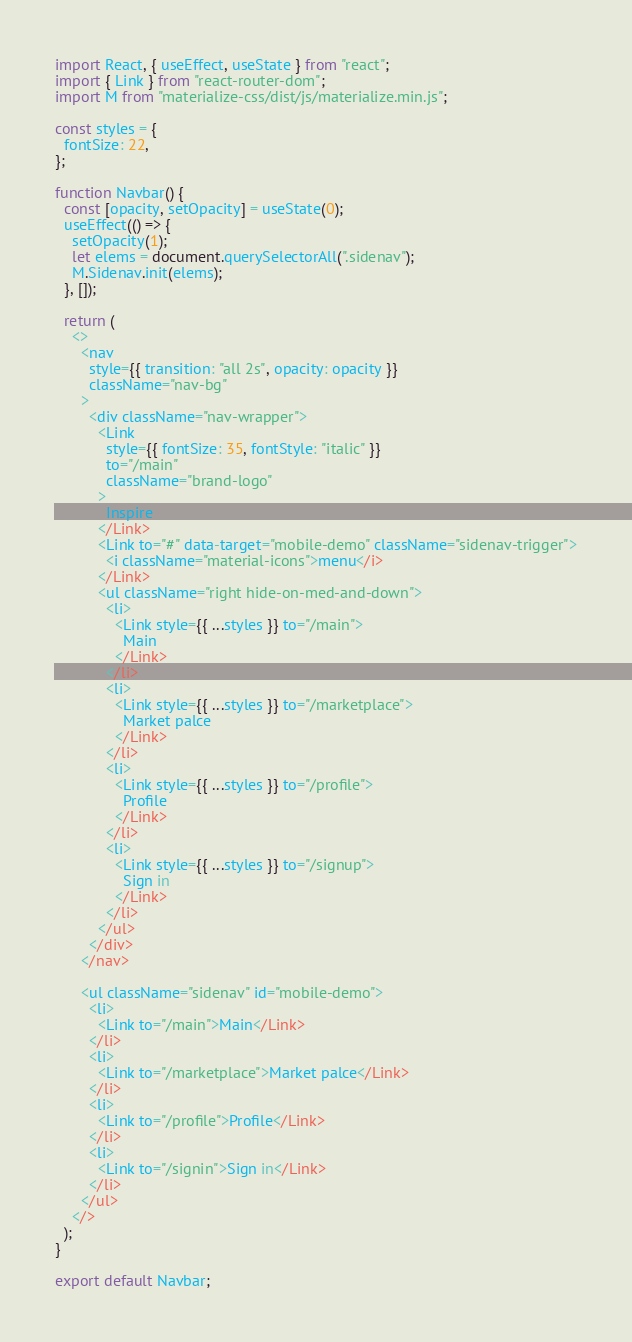<code> <loc_0><loc_0><loc_500><loc_500><_JavaScript_>import React, { useEffect, useState } from "react";
import { Link } from "react-router-dom";
import M from "materialize-css/dist/js/materialize.min.js";

const styles = {
  fontSize: 22,
};

function Navbar() {
  const [opacity, setOpacity] = useState(0);
  useEffect(() => {
    setOpacity(1);
    let elems = document.querySelectorAll(".sidenav");
    M.Sidenav.init(elems);
  }, []);

  return (
    <>
      <nav
        style={{ transition: "all 2s", opacity: opacity }}
        className="nav-bg"
      >
        <div className="nav-wrapper">
          <Link
            style={{ fontSize: 35, fontStyle: "italic" }}
            to="/main"
            className="brand-logo"
          >
            Inspire
          </Link>
          <Link to="#" data-target="mobile-demo" className="sidenav-trigger">
            <i className="material-icons">menu</i>
          </Link>
          <ul className="right hide-on-med-and-down">
            <li>
              <Link style={{ ...styles }} to="/main">
                Main
              </Link>
            </li>
            <li>
              <Link style={{ ...styles }} to="/marketplace">
                Market palce
              </Link>
            </li>
            <li>
              <Link style={{ ...styles }} to="/profile">
                Profile
              </Link>
            </li>
            <li>
              <Link style={{ ...styles }} to="/signup">
                Sign in
              </Link>
            </li>
          </ul>
        </div>
      </nav>

      <ul className="sidenav" id="mobile-demo">
        <li>
          <Link to="/main">Main</Link>
        </li>
        <li>
          <Link to="/marketplace">Market palce</Link>
        </li>
        <li>
          <Link to="/profile">Profile</Link>
        </li>
        <li>
          <Link to="/signin">Sign in</Link>
        </li>
      </ul>
    </>
  );
}

export default Navbar;
</code> 